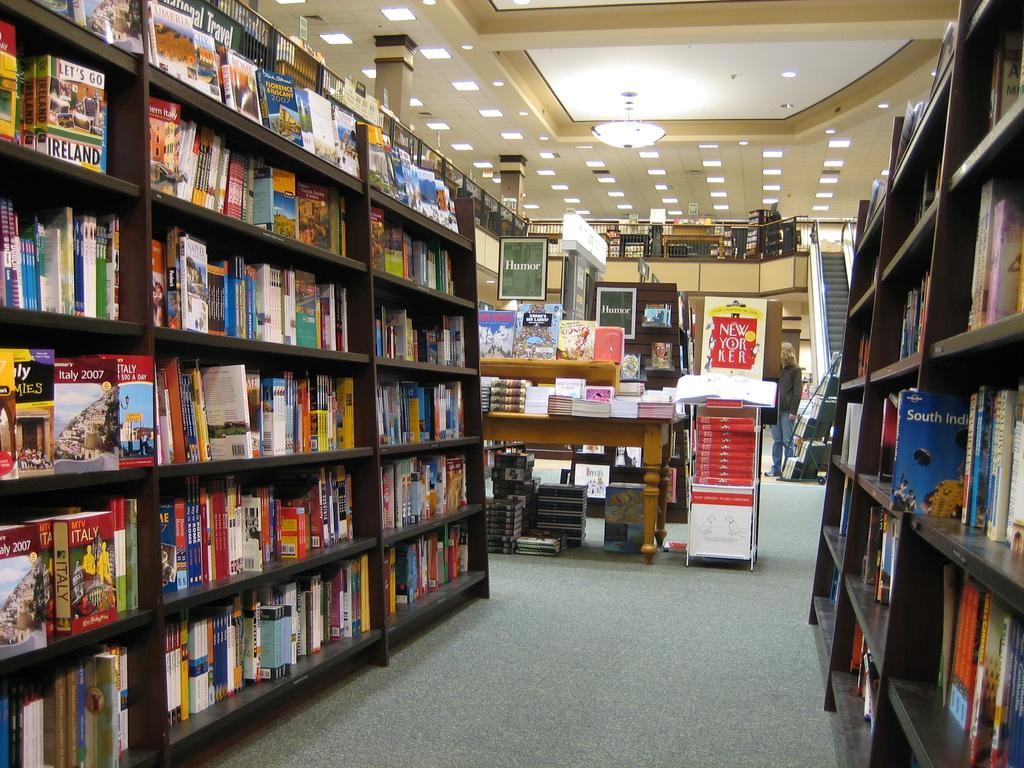What books do they have here?
Offer a very short reply. Humor. What is the title of the blue book sticking out on the right shelf in the center?
Offer a very short reply. South india. 